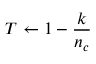<formula> <loc_0><loc_0><loc_500><loc_500>T \gets 1 - \frac { k } { n _ { c } }</formula> 